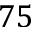Convert formula to latex. <formula><loc_0><loc_0><loc_500><loc_500>7 5</formula> 